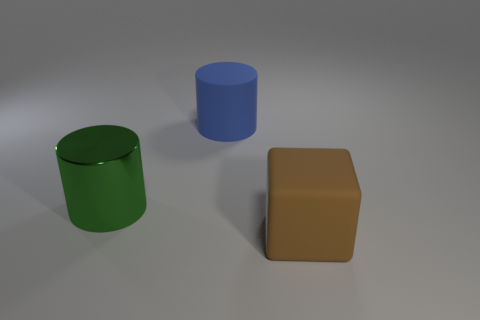Subtract all blue cylinders. How many cylinders are left? 1 Subtract 1 cubes. How many cubes are left? 0 Add 3 large gray things. How many objects exist? 6 Subtract all cylinders. How many objects are left? 1 Subtract all purple spheres. How many green cylinders are left? 1 Subtract all large blue objects. Subtract all large green things. How many objects are left? 1 Add 3 blue things. How many blue things are left? 4 Add 2 large cyan rubber balls. How many large cyan rubber balls exist? 2 Subtract 0 green spheres. How many objects are left? 3 Subtract all green cubes. Subtract all green cylinders. How many cubes are left? 1 